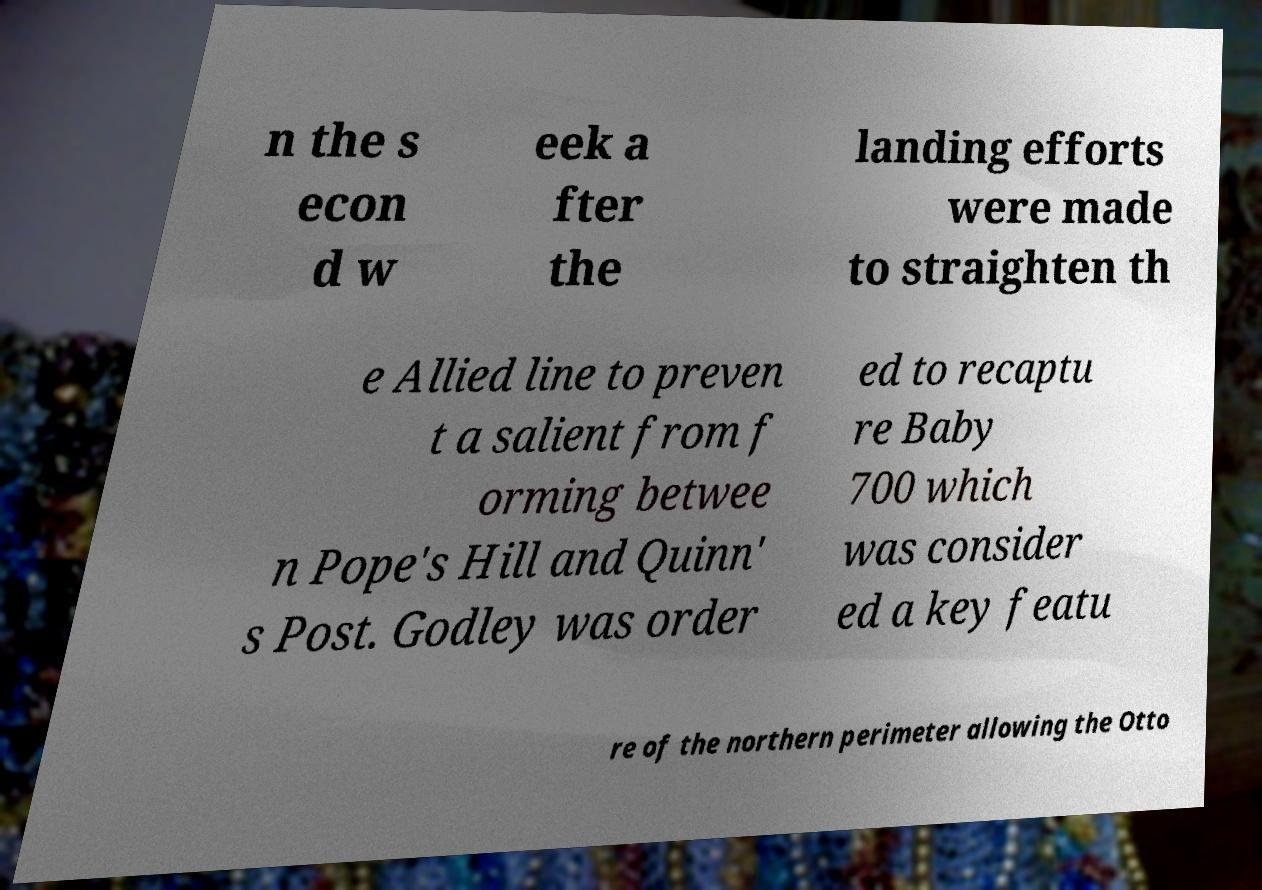Could you assist in decoding the text presented in this image and type it out clearly? n the s econ d w eek a fter the landing efforts were made to straighten th e Allied line to preven t a salient from f orming betwee n Pope's Hill and Quinn' s Post. Godley was order ed to recaptu re Baby 700 which was consider ed a key featu re of the northern perimeter allowing the Otto 